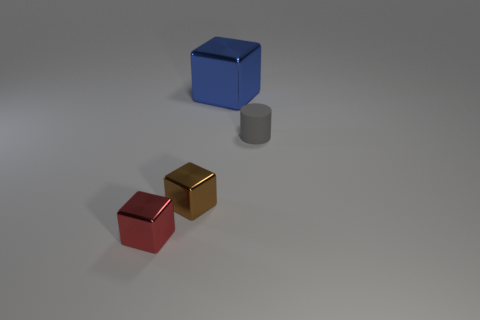Could you describe the lighting and shadows visible in the image? Certainly. The image shows diffuse lighting coming from above, as indicated by the soft, indistinct shadows cast by all objects. There is no harsh or direct light source visible, which creates a calm, evenly lit scene. The objects exhibit soft-edged shadows to their right sides, suggesting a light source located to the top left of the objects, slightly in front of them. 